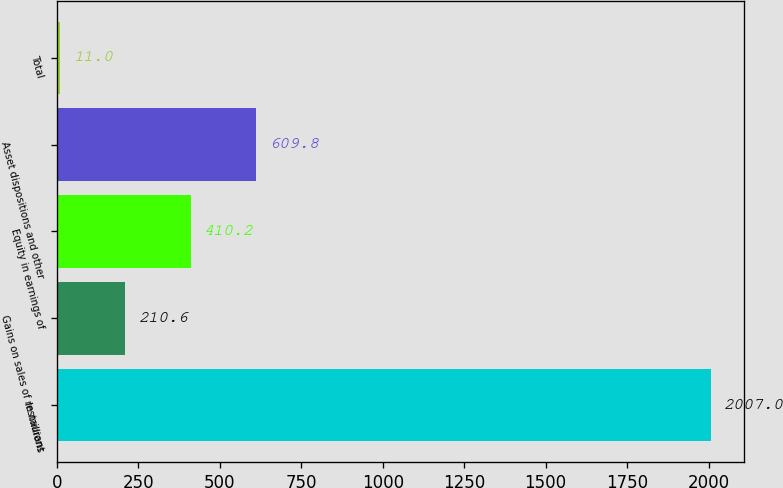Convert chart. <chart><loc_0><loc_0><loc_500><loc_500><bar_chart><fcel>In millions<fcel>Gains on sales of restaurant<fcel>Equity in earnings of<fcel>Asset dispositions and other<fcel>Total<nl><fcel>2007<fcel>210.6<fcel>410.2<fcel>609.8<fcel>11<nl></chart> 